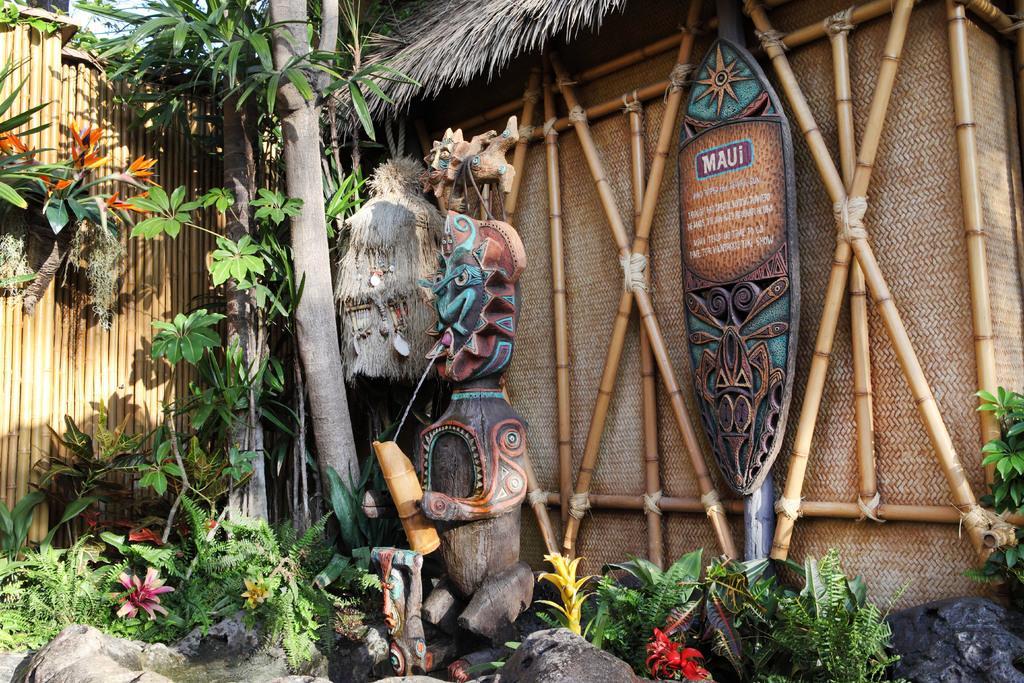How would you summarize this image in a sentence or two? In this image there is a fountain, beside the fountain there are plants, trees and a hut. 